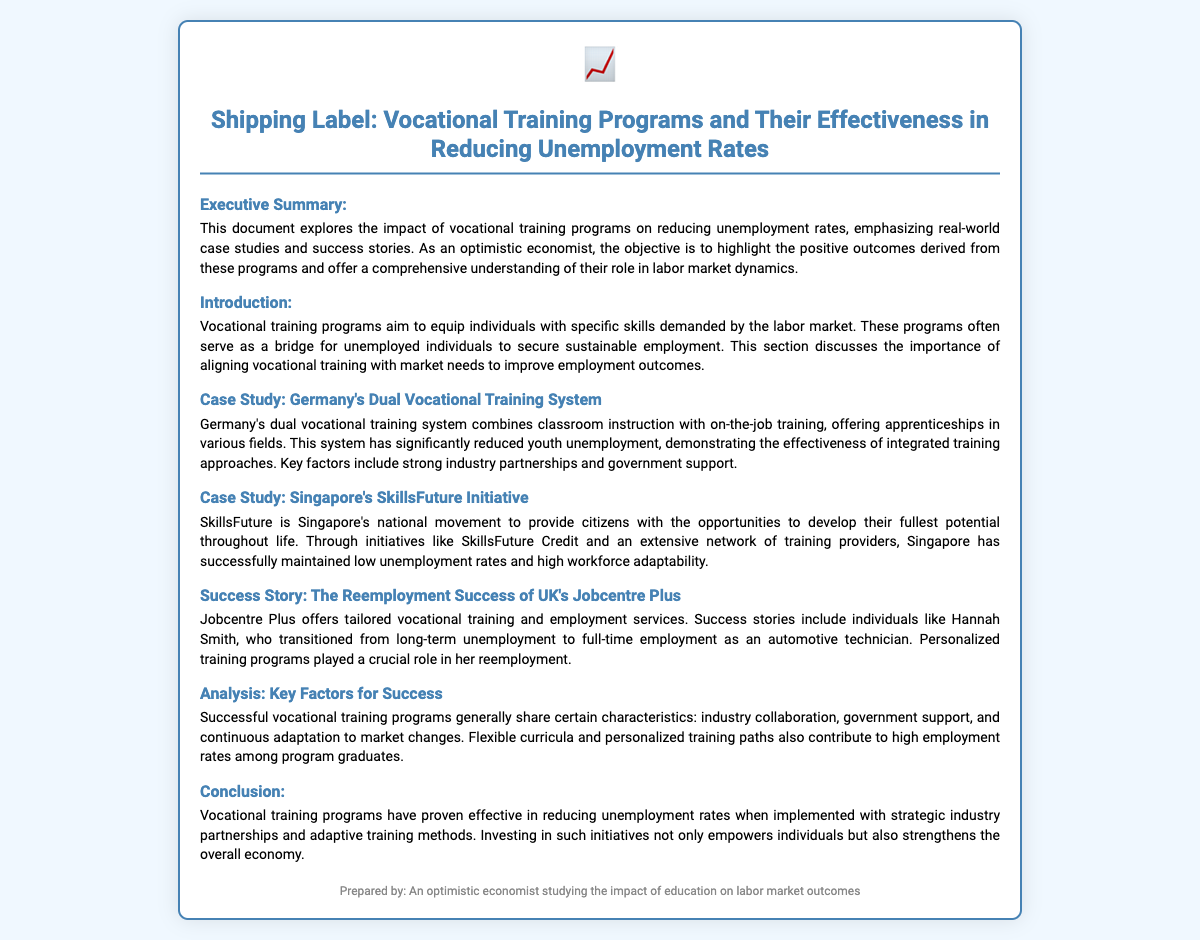what is the title of the document? The title is explicitly stated at the top of the document.
Answer: Shipping Label: Vocational Training Programs and Their Effectiveness in Reducing Unemployment Rates what is the main purpose of the document? The purpose is outlined in the Executive Summary section, focusing on the impact of vocational training programs.
Answer: To explore the impact of vocational training programs on reducing unemployment rates which country's vocational training system is highlighted in a case study? The document mentions specific countries in its case studies.
Answer: Germany what initiative is mentioned as part of Singapore's vocational training? The introduction of Singapore's program is specifically noted in the document.
Answer: SkillsFuture Initiative who is a success story featured in the document? The document lists individuals who benefited from training programs as success stories.
Answer: Hannah Smith what key factors contribute to successful vocational training programs? The Analysis section identifies factors that lead to successful programs.
Answer: Industry collaboration, government support, and continuous adaptation how does the document suggest vocational training impacts the economy? The conclusion summarizes the broader effects on the economy.
Answer: Strengthens the overall economy what type of document is this? The format and content indicate a specific type commonly used for transporting information.
Answer: Shipping Label 